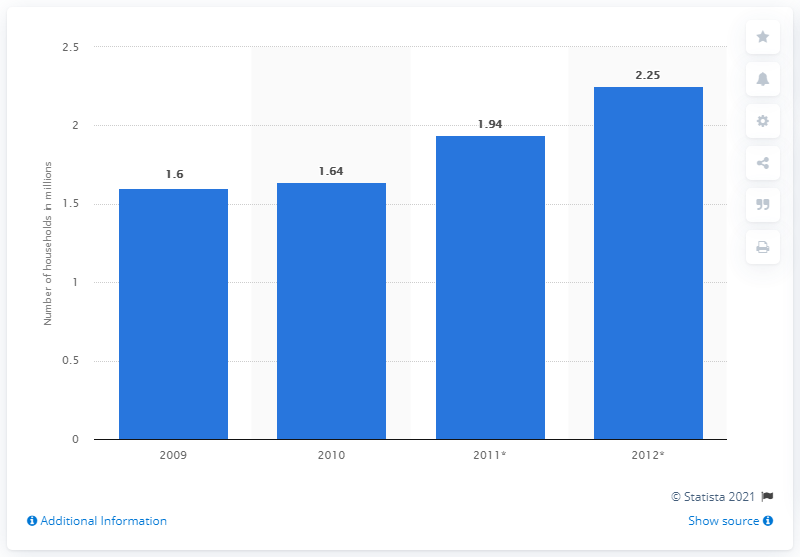Point out several critical features in this image. In 2010, approximately 1.6% of households in Hong Kong used a multichannel television service. 